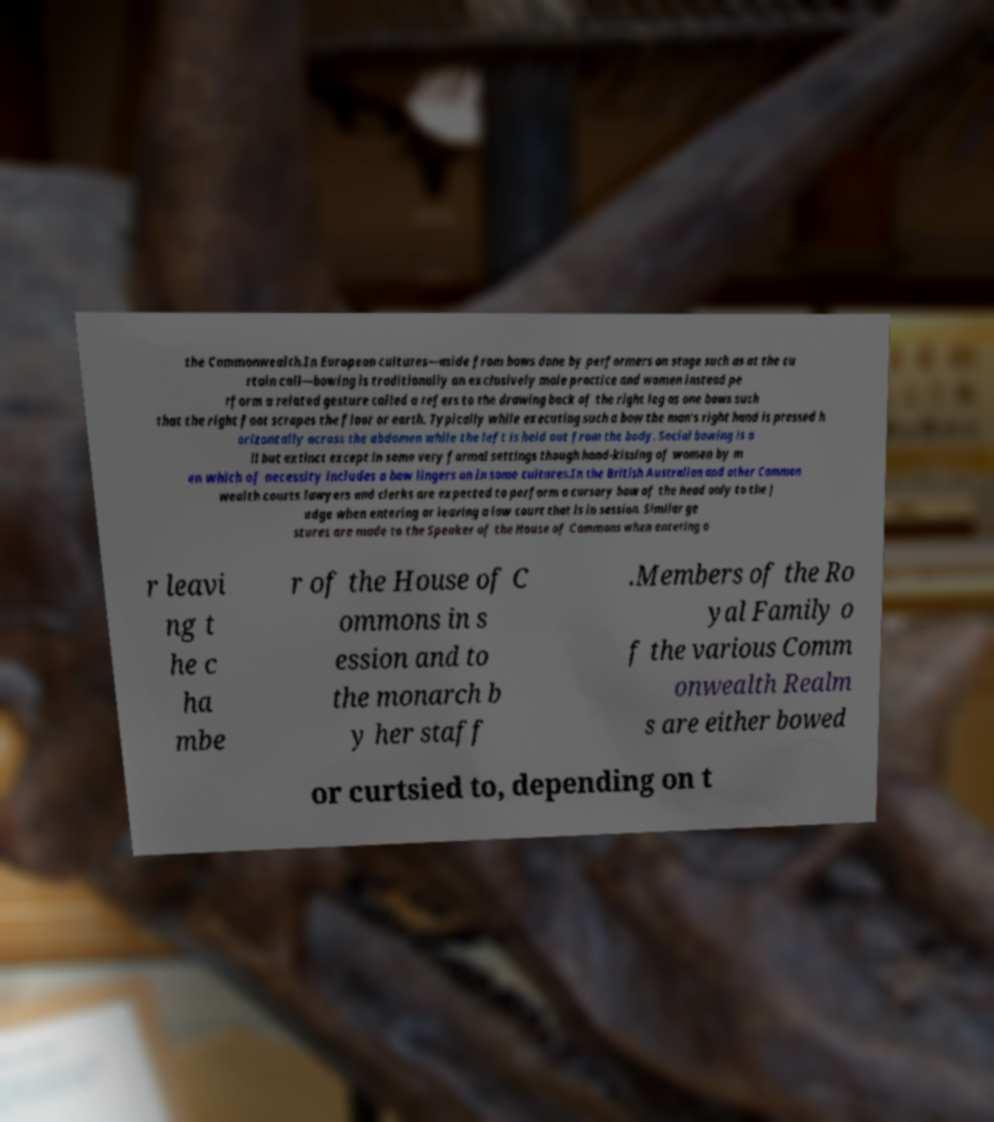What messages or text are displayed in this image? I need them in a readable, typed format. the Commonwealth.In European cultures—aside from bows done by performers on stage such as at the cu rtain call—bowing is traditionally an exclusively male practice and women instead pe rform a related gesture called a refers to the drawing back of the right leg as one bows such that the right foot scrapes the floor or earth. Typically while executing such a bow the man's right hand is pressed h orizontally across the abdomen while the left is held out from the body. Social bowing is a ll but extinct except in some very formal settings though hand-kissing of women by m en which of necessity includes a bow lingers on in some cultures.In the British Australian and other Common wealth courts lawyers and clerks are expected to perform a cursory bow of the head only to the j udge when entering or leaving a law court that is in session. Similar ge stures are made to the Speaker of the House of Commons when entering o r leavi ng t he c ha mbe r of the House of C ommons in s ession and to the monarch b y her staff .Members of the Ro yal Family o f the various Comm onwealth Realm s are either bowed or curtsied to, depending on t 